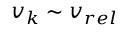Convert formula to latex. <formula><loc_0><loc_0><loc_500><loc_500>v _ { k } \sim v _ { r e l }</formula> 